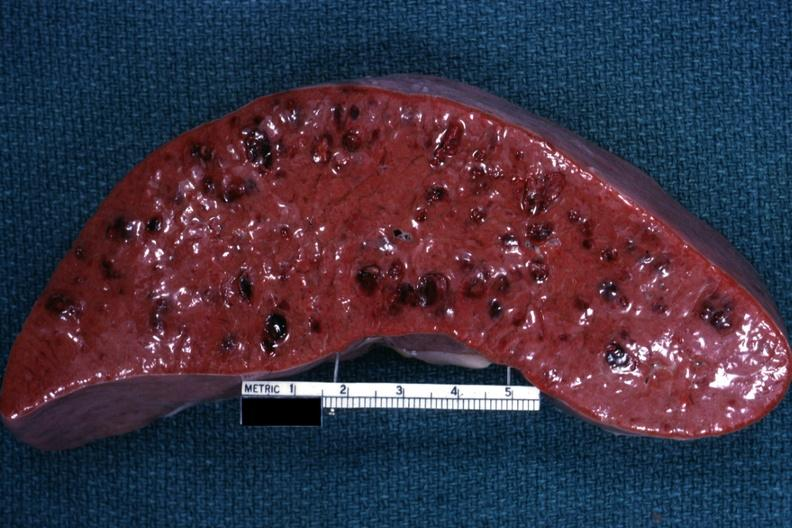s hematologic present?
Answer the question using a single word or phrase. Yes 